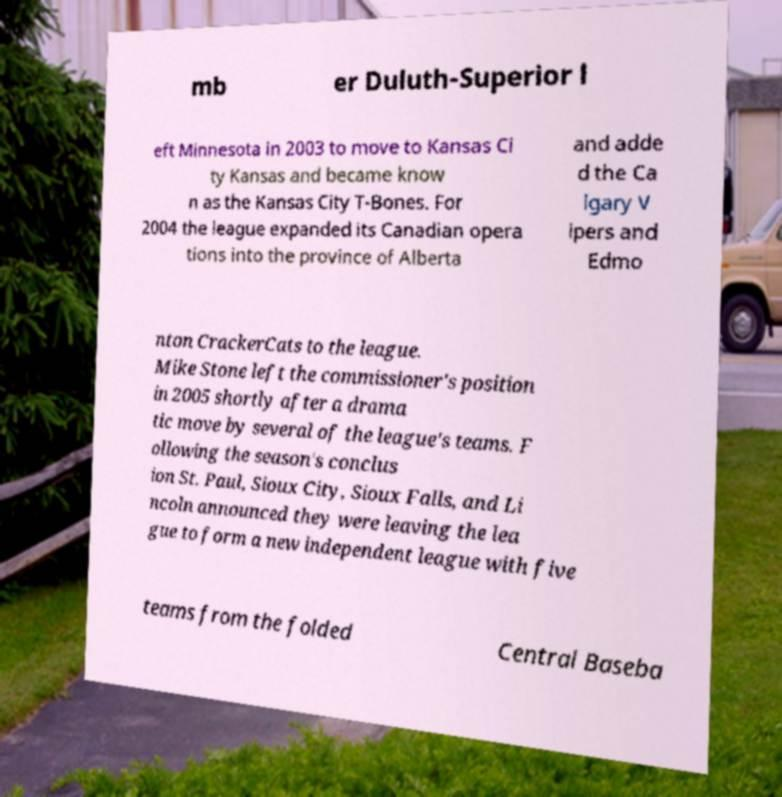Can you read and provide the text displayed in the image?This photo seems to have some interesting text. Can you extract and type it out for me? mb er Duluth-Superior l eft Minnesota in 2003 to move to Kansas Ci ty Kansas and became know n as the Kansas City T-Bones. For 2004 the league expanded its Canadian opera tions into the province of Alberta and adde d the Ca lgary V ipers and Edmo nton CrackerCats to the league. Mike Stone left the commissioner's position in 2005 shortly after a drama tic move by several of the league's teams. F ollowing the season's conclus ion St. Paul, Sioux City, Sioux Falls, and Li ncoln announced they were leaving the lea gue to form a new independent league with five teams from the folded Central Baseba 